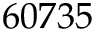Convert formula to latex. <formula><loc_0><loc_0><loc_500><loc_500>6 0 7 3 5</formula> 